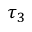<formula> <loc_0><loc_0><loc_500><loc_500>\tau _ { 3 }</formula> 